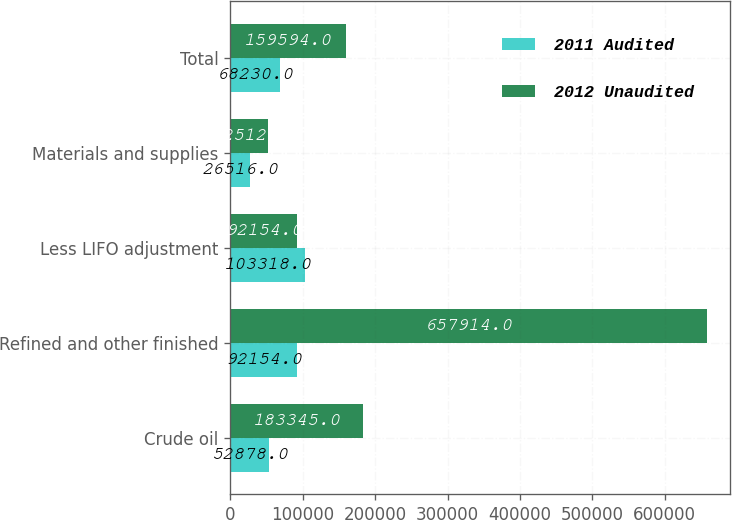Convert chart to OTSL. <chart><loc_0><loc_0><loc_500><loc_500><stacked_bar_chart><ecel><fcel>Crude oil<fcel>Refined and other finished<fcel>Less LIFO adjustment<fcel>Materials and supplies<fcel>Total<nl><fcel>2011 Audited<fcel>52878<fcel>92154<fcel>103318<fcel>26516<fcel>68230<nl><fcel>2012 Unaudited<fcel>183345<fcel>657914<fcel>92154<fcel>52512<fcel>159594<nl></chart> 